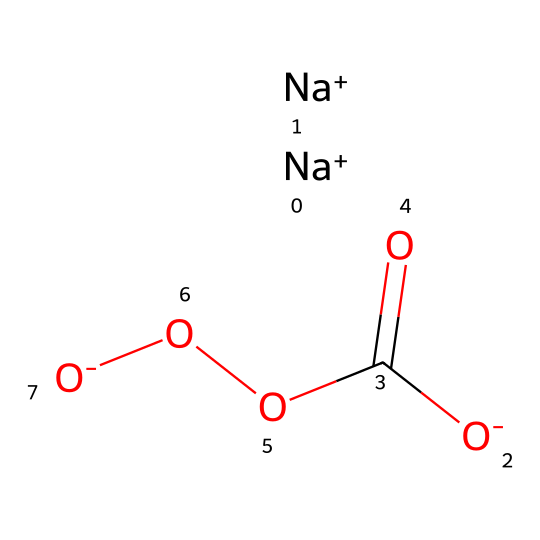What is the total number of oxygen atoms in the chemical? By analyzing the SMILES notation, we can identify the presence of three oxygen atoms: one in the carboxyl group (C(=O)) and two in the peroxide function (OO) as indicated. Counting these gives us a total of three oxygen atoms.
Answer: three How many sodium ions are present in this molecule? The notation [Na+] appears twice in the SMILES, indicating that there are two sodium ions. Thus, by counting the occurrences of [Na+], we determine that there are two sodium ions present in the chemical.
Answer: two What functional groups are identifiable in this detergent? The chemical has a carboxylic acid group (-C(=O)OO) and a peroxide group (OO). Both groups are responsible for the functionality of the detergent and their corresponding properties. By locating these groups in the structure, we identify the functional groups present.
Answer: carboxylic acid, peroxide What is the overall charge of the chemical? The chemical contains two sodium cations ([Na+]) which carry a positive charge and one carboxylate anion ([O-]C(=O)O) and two peroxides ([O-]) which are also negatively charged. The overall charge can be calculated as two positive charges (from sodium) and three negative charges (from two peroxides and one carboxylate), resulting in an overall charge of -1.
Answer: -1 What type of chemical is represented by this SMILES notation? The presence of a carboxylic acid functional group along with peroxide groups indicates that this is a detergent, specifically an oxygen-producing detergent due to its structure that supports oxygen liberation. By recognizing the functional groups these are associated with detergents, we confidently classify the type of chemical.
Answer: detergent What property is contributed by the peroxide group in this detergent? The peroxide group is known for its properties of decomposing to release oxygen upon activation, which is crucial in life support systems for sustaining aerobic organisms in enclosed environments like Mars. So, the property contributed is oxygen release.
Answer: oxygen release 